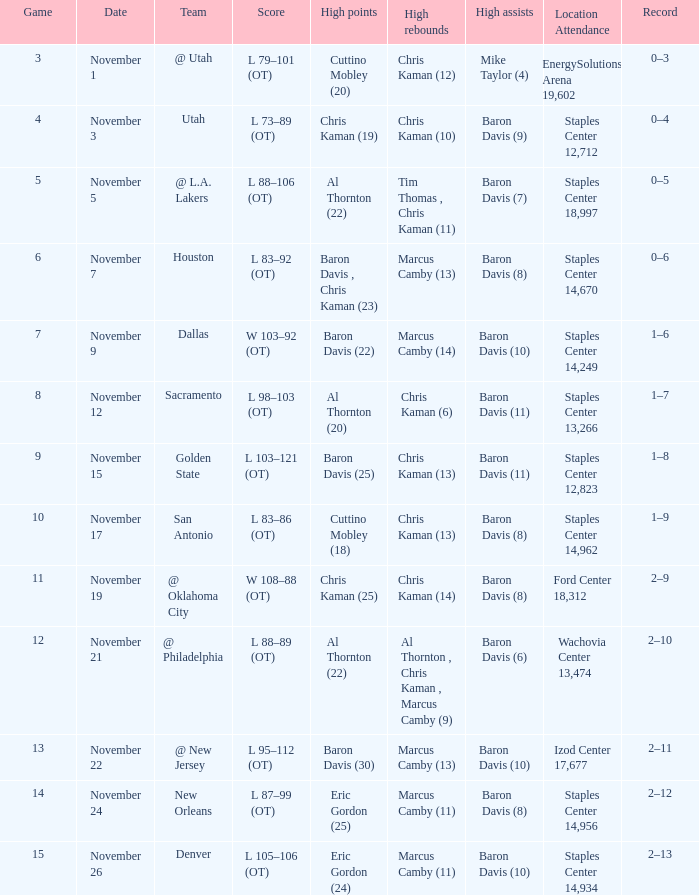I'm looking to parse the entire table for insights. Could you assist me with that? {'header': ['Game', 'Date', 'Team', 'Score', 'High points', 'High rebounds', 'High assists', 'Location Attendance', 'Record'], 'rows': [['3', 'November 1', '@ Utah', 'L 79–101 (OT)', 'Cuttino Mobley (20)', 'Chris Kaman (12)', 'Mike Taylor (4)', 'EnergySolutions Arena 19,602', '0–3'], ['4', 'November 3', 'Utah', 'L 73–89 (OT)', 'Chris Kaman (19)', 'Chris Kaman (10)', 'Baron Davis (9)', 'Staples Center 12,712', '0–4'], ['5', 'November 5', '@ L.A. Lakers', 'L 88–106 (OT)', 'Al Thornton (22)', 'Tim Thomas , Chris Kaman (11)', 'Baron Davis (7)', 'Staples Center 18,997', '0–5'], ['6', 'November 7', 'Houston', 'L 83–92 (OT)', 'Baron Davis , Chris Kaman (23)', 'Marcus Camby (13)', 'Baron Davis (8)', 'Staples Center 14,670', '0–6'], ['7', 'November 9', 'Dallas', 'W 103–92 (OT)', 'Baron Davis (22)', 'Marcus Camby (14)', 'Baron Davis (10)', 'Staples Center 14,249', '1–6'], ['8', 'November 12', 'Sacramento', 'L 98–103 (OT)', 'Al Thornton (20)', 'Chris Kaman (6)', 'Baron Davis (11)', 'Staples Center 13,266', '1–7'], ['9', 'November 15', 'Golden State', 'L 103–121 (OT)', 'Baron Davis (25)', 'Chris Kaman (13)', 'Baron Davis (11)', 'Staples Center 12,823', '1–8'], ['10', 'November 17', 'San Antonio', 'L 83–86 (OT)', 'Cuttino Mobley (18)', 'Chris Kaman (13)', 'Baron Davis (8)', 'Staples Center 14,962', '1–9'], ['11', 'November 19', '@ Oklahoma City', 'W 108–88 (OT)', 'Chris Kaman (25)', 'Chris Kaman (14)', 'Baron Davis (8)', 'Ford Center 18,312', '2–9'], ['12', 'November 21', '@ Philadelphia', 'L 88–89 (OT)', 'Al Thornton (22)', 'Al Thornton , Chris Kaman , Marcus Camby (9)', 'Baron Davis (6)', 'Wachovia Center 13,474', '2–10'], ['13', 'November 22', '@ New Jersey', 'L 95–112 (OT)', 'Baron Davis (30)', 'Marcus Camby (13)', 'Baron Davis (10)', 'Izod Center 17,677', '2–11'], ['14', 'November 24', 'New Orleans', 'L 87–99 (OT)', 'Eric Gordon (25)', 'Marcus Camby (11)', 'Baron Davis (8)', 'Staples Center 14,956', '2–12'], ['15', 'November 26', 'Denver', 'L 105–106 (OT)', 'Eric Gordon (24)', 'Marcus Camby (11)', 'Baron Davis (10)', 'Staples Center 14,934', '2–13']]} What is the sum of scores at the staples center, equating to 13,266? 1.0. 